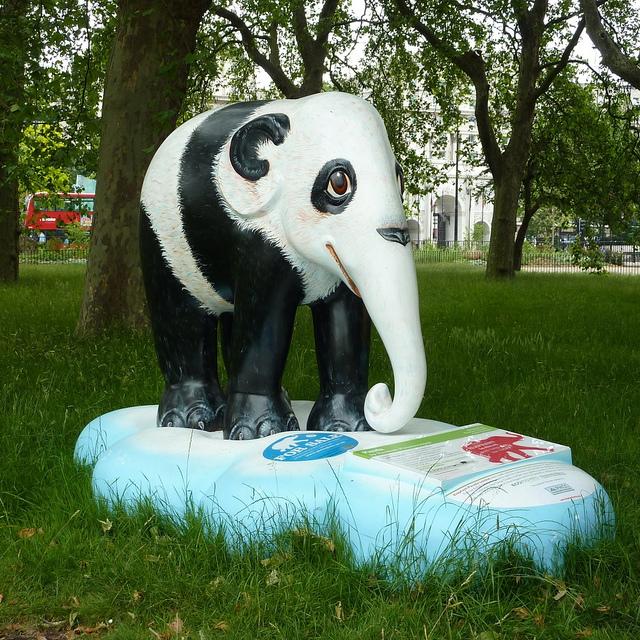Is the animal in this picture a mutant?
Keep it brief. Yes. What color is the bus in the background?
Give a very brief answer. Red. Is this a real elephant?
Be succinct. No. 